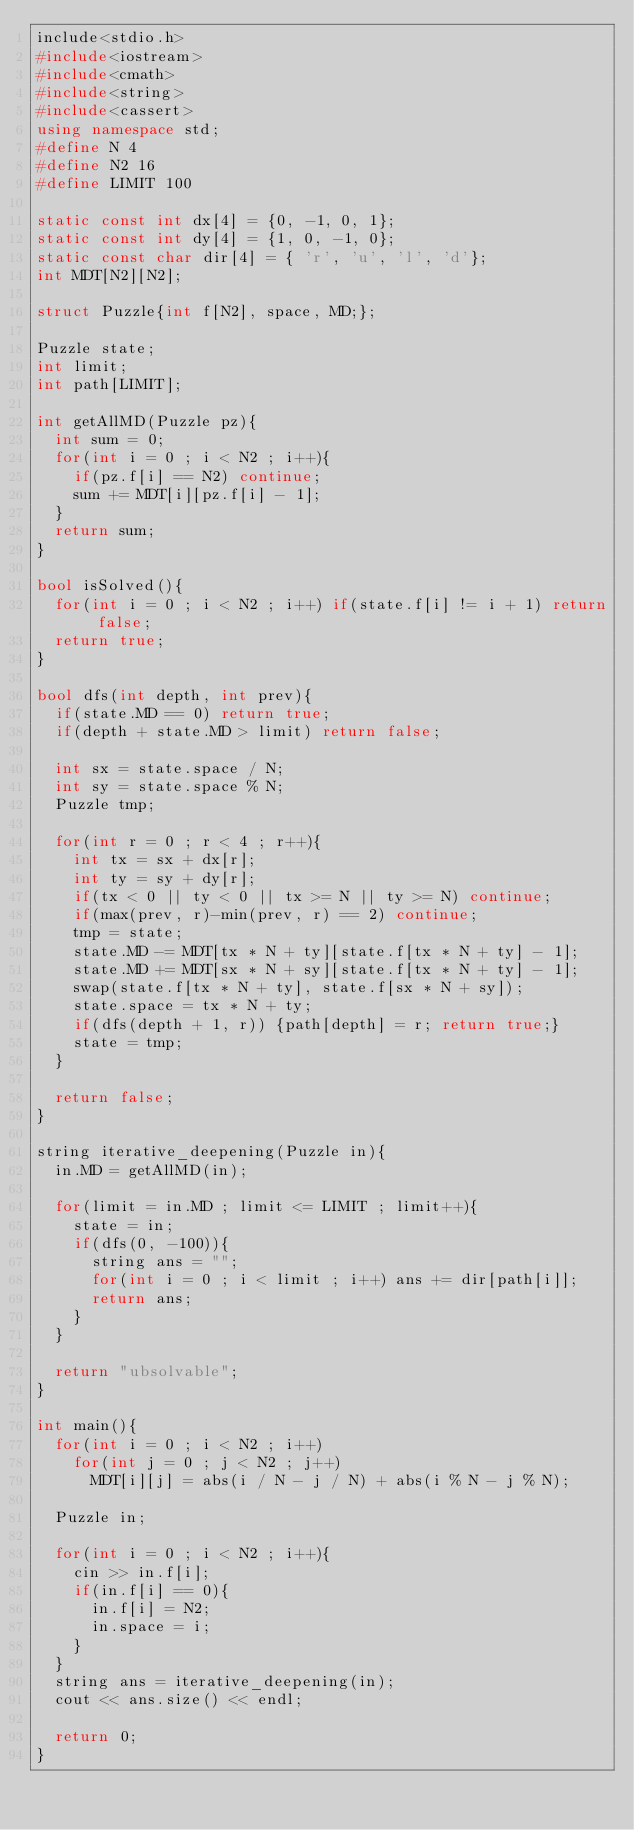Convert code to text. <code><loc_0><loc_0><loc_500><loc_500><_C++_>include<stdio.h>
#include<iostream>
#include<cmath>
#include<string>
#include<cassert>
using namespace std;
#define N 4
#define N2 16
#define LIMIT 100
 
static const int dx[4] = {0, -1, 0, 1};
static const int dy[4] = {1, 0, -1, 0};
static const char dir[4] = { 'r', 'u', 'l', 'd'};
int MDT[N2][N2];
 
struct Puzzle{int f[N2], space, MD;};
 
Puzzle state;
int limit;
int path[LIMIT];
 
int getAllMD(Puzzle pz){
  int sum = 0;
  for(int i = 0 ; i < N2 ; i++){
    if(pz.f[i] == N2) continue;
    sum += MDT[i][pz.f[i] - 1];
  }
  return sum;
}
 
bool isSolved(){
  for(int i = 0 ; i < N2 ; i++) if(state.f[i] != i + 1) return false;
  return true;
}
 
bool dfs(int depth, int prev){
  if(state.MD == 0) return true;
  if(depth + state.MD > limit) return false;
 
  int sx = state.space / N;
  int sy = state.space % N;
  Puzzle tmp;
 
  for(int r = 0 ; r < 4 ; r++){
    int tx = sx + dx[r];
    int ty = sy + dy[r];
    if(tx < 0 || ty < 0 || tx >= N || ty >= N) continue;
    if(max(prev, r)-min(prev, r) == 2) continue;
    tmp = state;
    state.MD -= MDT[tx * N + ty][state.f[tx * N + ty] - 1];
    state.MD += MDT[sx * N + sy][state.f[tx * N + ty] - 1];
    swap(state.f[tx * N + ty], state.f[sx * N + sy]);
    state.space = tx * N + ty;
    if(dfs(depth + 1, r)) {path[depth] = r; return true;}
    state = tmp;
  }
 
  return false;
}
 
string iterative_deepening(Puzzle in){
  in.MD = getAllMD(in);
 
  for(limit = in.MD ; limit <= LIMIT ; limit++){
    state = in;
    if(dfs(0, -100)){
      string ans = "";
      for(int i = 0 ; i < limit ; i++) ans += dir[path[i]];
      return ans;
    }
  }
 
  return "ubsolvable";
}
 
int main(){
  for(int i = 0 ; i < N2 ; i++)
    for(int j = 0 ; j < N2 ; j++)
      MDT[i][j] = abs(i / N - j / N) + abs(i % N - j % N);
 
  Puzzle in;
 
  for(int i = 0 ; i < N2 ; i++){
    cin >> in.f[i];
    if(in.f[i] == 0){
      in.f[i] = N2;
      in.space = i;
    }
  }
  string ans = iterative_deepening(in);
  cout << ans.size() << endl;
 
  return 0;
}</code> 